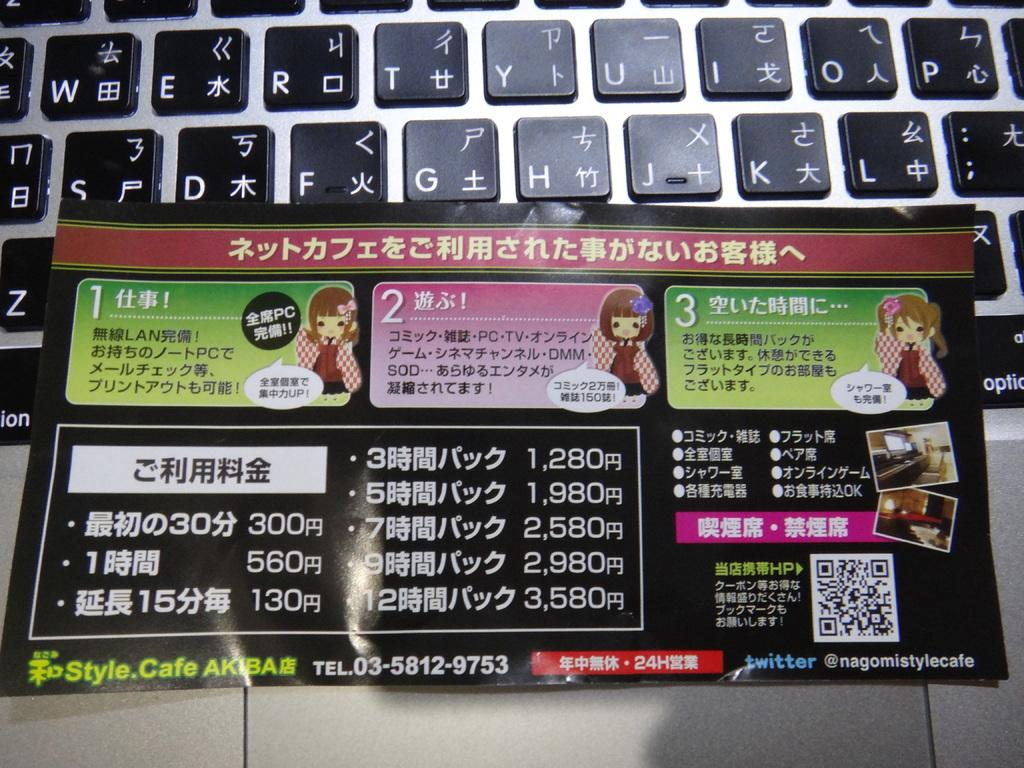<image>
Relay a brief, clear account of the picture shown. A Chinese instruction leaflet sits on a computer keybopard that has normal letters and chinese writing on its keys. 